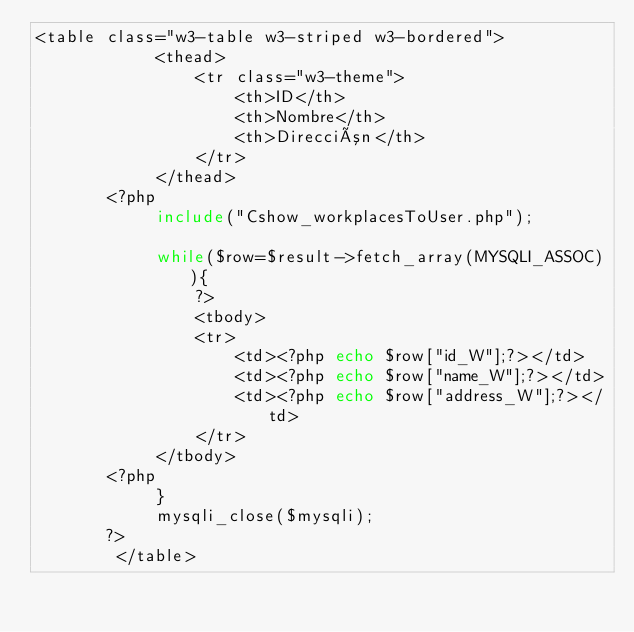<code> <loc_0><loc_0><loc_500><loc_500><_PHP_><table class="w3-table w3-striped w3-bordered">
            <thead>
                <tr class="w3-theme">
                    <th>ID</th>
                    <th>Nombre</th>
                    <th>Dirección</th>
                </tr>
            </thead>
       <?php 
            include("Cshow_workplacesToUser.php");
            
            while($row=$result->fetch_array(MYSQLI_ASSOC)){
                ?>
                <tbody>
                <tr>
                    <td><?php echo $row["id_W"];?></td>
                    <td><?php echo $row["name_W"];?></td>
                    <td><?php echo $row["address_W"];?></td>
                </tr>
            </tbody>
       <?php     
            }   
            mysqli_close($mysqli);  
       ?>     
        </table></code> 